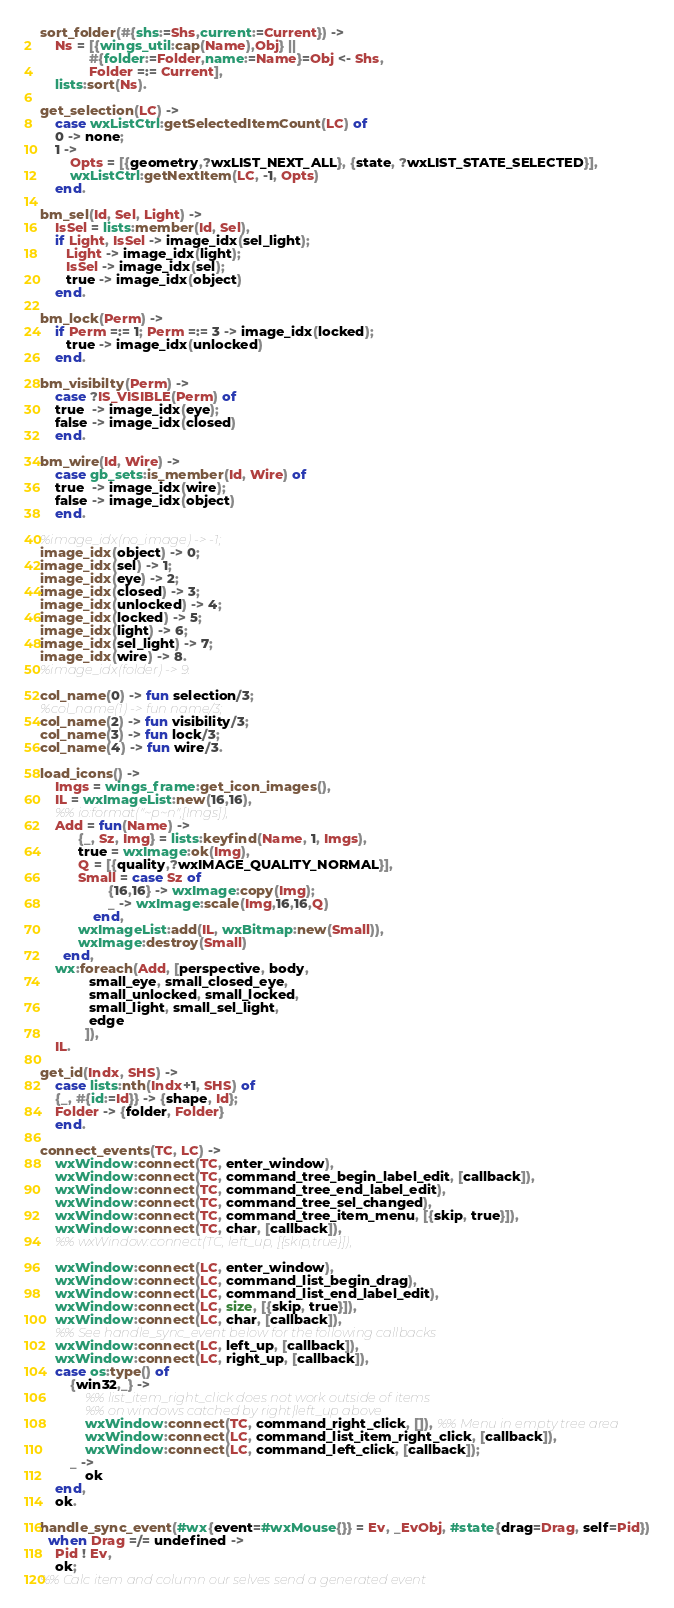<code> <loc_0><loc_0><loc_500><loc_500><_Erlang_>
sort_folder(#{shs:=Shs,current:=Current}) ->
    Ns = [{wings_util:cap(Name),Obj} ||
             #{folder:=Folder,name:=Name}=Obj <- Shs,
             Folder =:= Current],
    lists:sort(Ns).

get_selection(LC) ->
    case wxListCtrl:getSelectedItemCount(LC) of
	0 -> none;
	1 ->
	    Opts = [{geometry,?wxLIST_NEXT_ALL}, {state, ?wxLIST_STATE_SELECTED}],
	    wxListCtrl:getNextItem(LC, -1, Opts)
    end.

bm_sel(Id, Sel, Light) ->
    IsSel = lists:member(Id, Sel),
    if Light, IsSel -> image_idx(sel_light);
       Light -> image_idx(light);
       IsSel -> image_idx(sel);
       true -> image_idx(object)
    end.

bm_lock(Perm) ->
    if Perm =:= 1; Perm =:= 3 -> image_idx(locked);
       true -> image_idx(unlocked)
    end.

bm_visibilty(Perm) ->
    case ?IS_VISIBLE(Perm) of
	true  -> image_idx(eye);
	false -> image_idx(closed)
    end.

bm_wire(Id, Wire) ->
    case gb_sets:is_member(Id, Wire) of
	true  -> image_idx(wire);
	false -> image_idx(object)
    end.

%image_idx(no_image) -> -1;
image_idx(object) -> 0;
image_idx(sel) -> 1;
image_idx(eye) -> 2;
image_idx(closed) -> 3;
image_idx(unlocked) -> 4;
image_idx(locked) -> 5;
image_idx(light) -> 6;
image_idx(sel_light) -> 7;
image_idx(wire) -> 8.
%image_idx(folder) -> 9.

col_name(0) -> fun selection/3;
%col_name(1) -> fun name/3;
col_name(2) -> fun visibility/3;
col_name(3) -> fun lock/3;
col_name(4) -> fun wire/3.

load_icons() ->
    Imgs = wings_frame:get_icon_images(),
    IL = wxImageList:new(16,16),
    %% io:format("~p~n",[Imgs]),
    Add = fun(Name) ->
		  {_, Sz, Img} = lists:keyfind(Name, 1, Imgs),
		  true = wxImage:ok(Img),
		  Q = [{quality,?wxIMAGE_QUALITY_NORMAL}],
		  Small = case Sz of
			      {16,16} -> wxImage:copy(Img);
			      _ -> wxImage:scale(Img,16,16,Q)
			  end,
		  wxImageList:add(IL, wxBitmap:new(Small)),
		  wxImage:destroy(Small)
	  end,
    wx:foreach(Add, [perspective, body,
		     small_eye, small_closed_eye,
		     small_unlocked, small_locked,
		     small_light, small_sel_light,
		     edge
		    ]),
    IL.

get_id(Indx, SHS) ->
    case lists:nth(Indx+1, SHS) of
	{_, #{id:=Id}} -> {shape, Id};
	Folder -> {folder, Folder}
    end.

connect_events(TC, LC) ->
    wxWindow:connect(TC, enter_window),
    wxWindow:connect(TC, command_tree_begin_label_edit, [callback]),
    wxWindow:connect(TC, command_tree_end_label_edit),
    wxWindow:connect(TC, command_tree_sel_changed),
    wxWindow:connect(TC, command_tree_item_menu, [{skip, true}]),
    wxWindow:connect(TC, char, [callback]),
    %% wxWindow:connect(TC, left_up, [{skip,true}]),

    wxWindow:connect(LC, enter_window),
    wxWindow:connect(LC, command_list_begin_drag),
    wxWindow:connect(LC, command_list_end_label_edit),
    wxWindow:connect(LC, size, [{skip, true}]),
    wxWindow:connect(LC, char, [callback]),
    %% See handle_sync_event below for the following callbacks
    wxWindow:connect(LC, left_up, [callback]),
    wxWindow:connect(LC, right_up, [callback]),
    case os:type() of
    	{win32,_} ->
            %% list_item_right_click does not work outside of items
            %% on windows catched by right|left_up above
            wxWindow:connect(TC, command_right_click, []), %% Menu in empty tree area
            wxWindow:connect(LC, command_list_item_right_click, [callback]),
            wxWindow:connect(LC, command_left_click, [callback]);
    	_ ->
    	    ok
    end,
    ok.

handle_sync_event(#wx{event=#wxMouse{}} = Ev, _EvObj, #state{drag=Drag, self=Pid})
  when Drag =/= undefined ->
    Pid ! Ev,
    ok;
%% Calc item and column our selves send a generated event</code> 